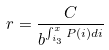<formula> <loc_0><loc_0><loc_500><loc_500>r = \frac { C } { b ^ { \int _ { i _ { 3 } } ^ { x } P ( i ) d i } }</formula> 